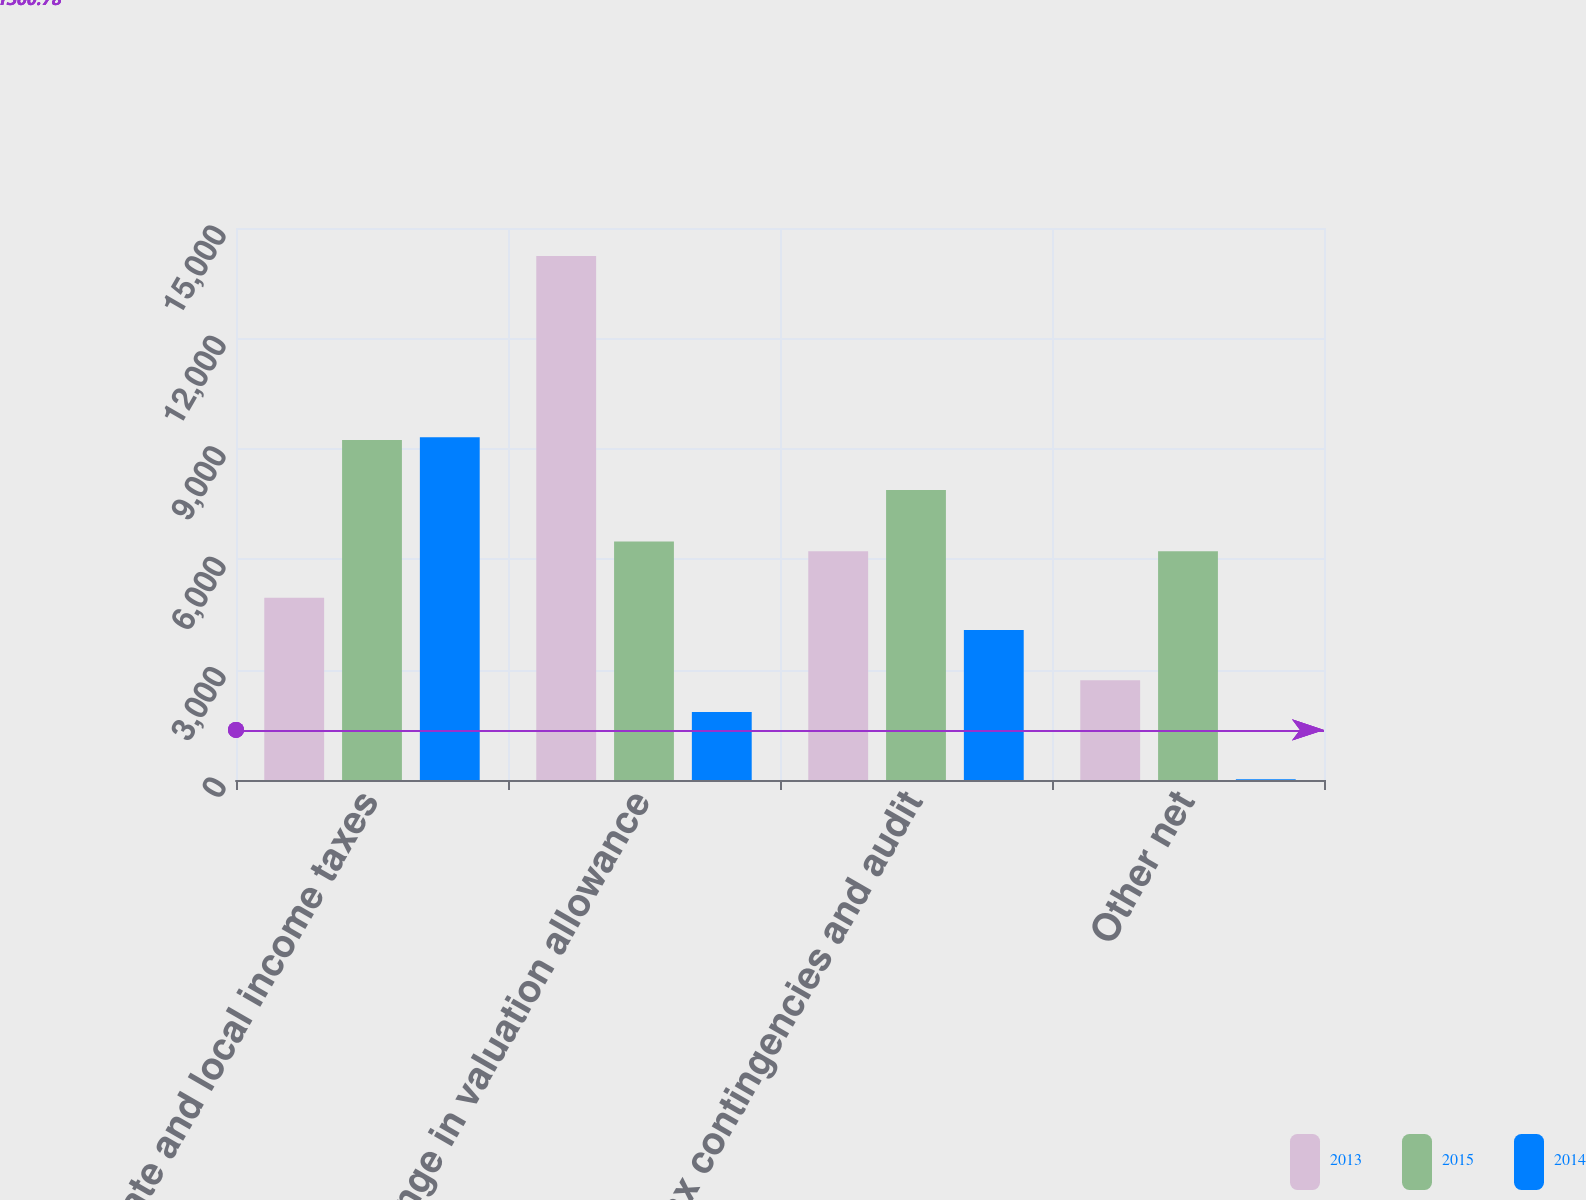Convert chart. <chart><loc_0><loc_0><loc_500><loc_500><stacked_bar_chart><ecel><fcel>State and local income taxes<fcel>Change in valuation allowance<fcel>Tax contingencies and audit<fcel>Other net<nl><fcel>2013<fcel>4951<fcel>14237<fcel>6215<fcel>2711<nl><fcel>2015<fcel>9239<fcel>6482<fcel>7882<fcel>6215<nl><fcel>2014<fcel>9317<fcel>1846<fcel>4076<fcel>23<nl></chart> 